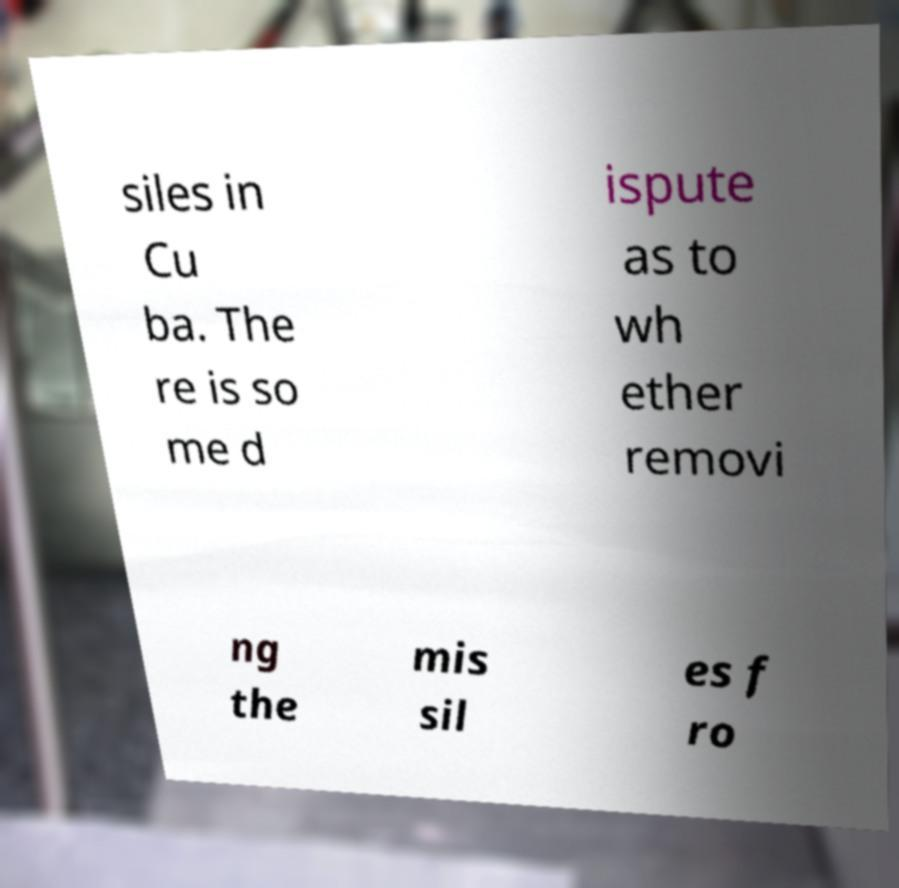Could you extract and type out the text from this image? siles in Cu ba. The re is so me d ispute as to wh ether removi ng the mis sil es f ro 